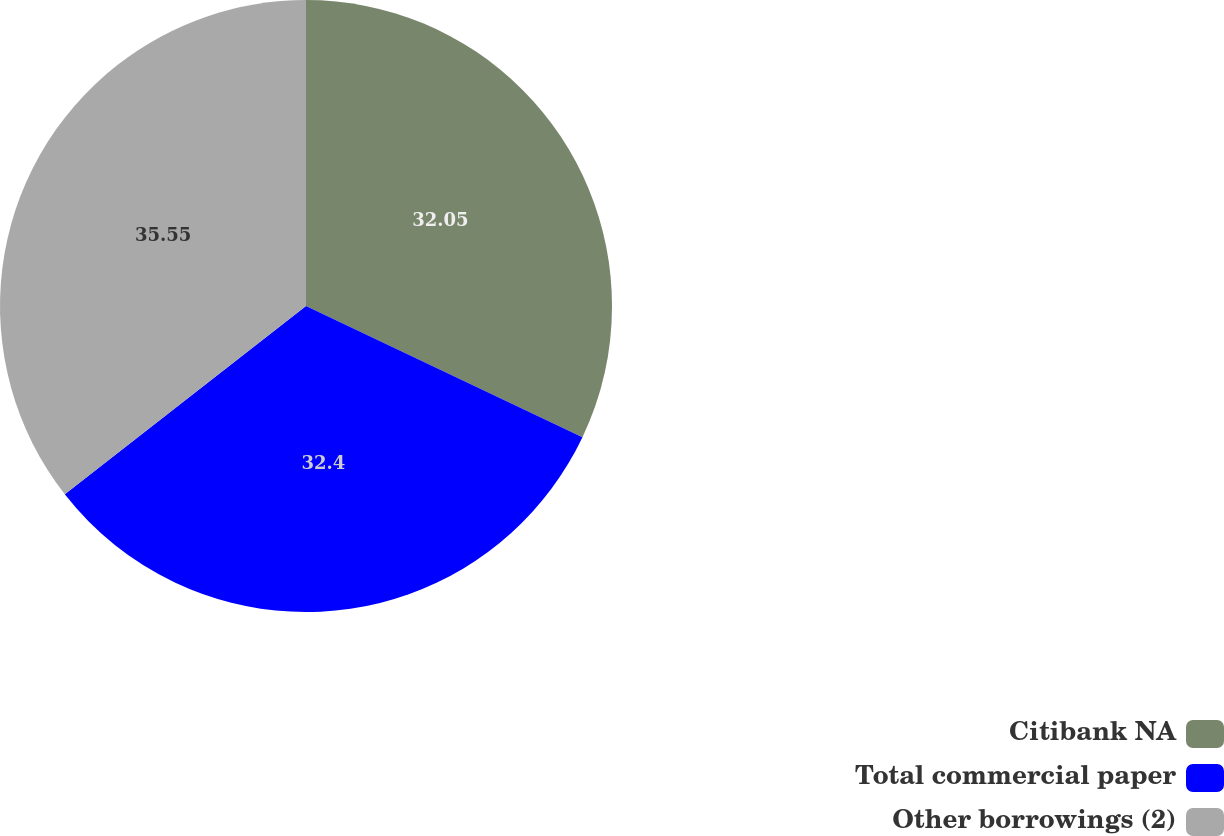Convert chart. <chart><loc_0><loc_0><loc_500><loc_500><pie_chart><fcel>Citibank NA<fcel>Total commercial paper<fcel>Other borrowings (2)<nl><fcel>32.05%<fcel>32.4%<fcel>35.55%<nl></chart> 